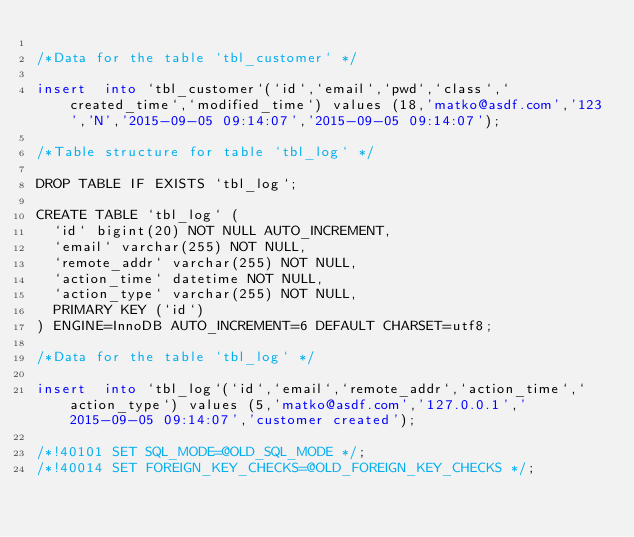<code> <loc_0><loc_0><loc_500><loc_500><_SQL_>
/*Data for the table `tbl_customer` */

insert  into `tbl_customer`(`id`,`email`,`pwd`,`class`,`created_time`,`modified_time`) values (18,'matko@asdf.com','123','N','2015-09-05 09:14:07','2015-09-05 09:14:07');

/*Table structure for table `tbl_log` */

DROP TABLE IF EXISTS `tbl_log`;

CREATE TABLE `tbl_log` (
  `id` bigint(20) NOT NULL AUTO_INCREMENT,
  `email` varchar(255) NOT NULL,
  `remote_addr` varchar(255) NOT NULL,
  `action_time` datetime NOT NULL,
  `action_type` varchar(255) NOT NULL,
  PRIMARY KEY (`id`)
) ENGINE=InnoDB AUTO_INCREMENT=6 DEFAULT CHARSET=utf8;

/*Data for the table `tbl_log` */

insert  into `tbl_log`(`id`,`email`,`remote_addr`,`action_time`,`action_type`) values (5,'matko@asdf.com','127.0.0.1','2015-09-05 09:14:07','customer created');

/*!40101 SET SQL_MODE=@OLD_SQL_MODE */;
/*!40014 SET FOREIGN_KEY_CHECKS=@OLD_FOREIGN_KEY_CHECKS */;
</code> 